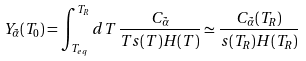Convert formula to latex. <formula><loc_0><loc_0><loc_500><loc_500>Y _ { \tilde { \alpha } } ( T _ { 0 } ) = \int _ { T _ { e q } } ^ { T _ { R } } d T \, \frac { C _ { \tilde { \alpha } } } { T s ( T ) H ( T ) } \simeq \frac { C _ { \tilde { \alpha } } ( T _ { R } ) } { s ( T _ { R } ) H ( T _ { R } ) }</formula> 